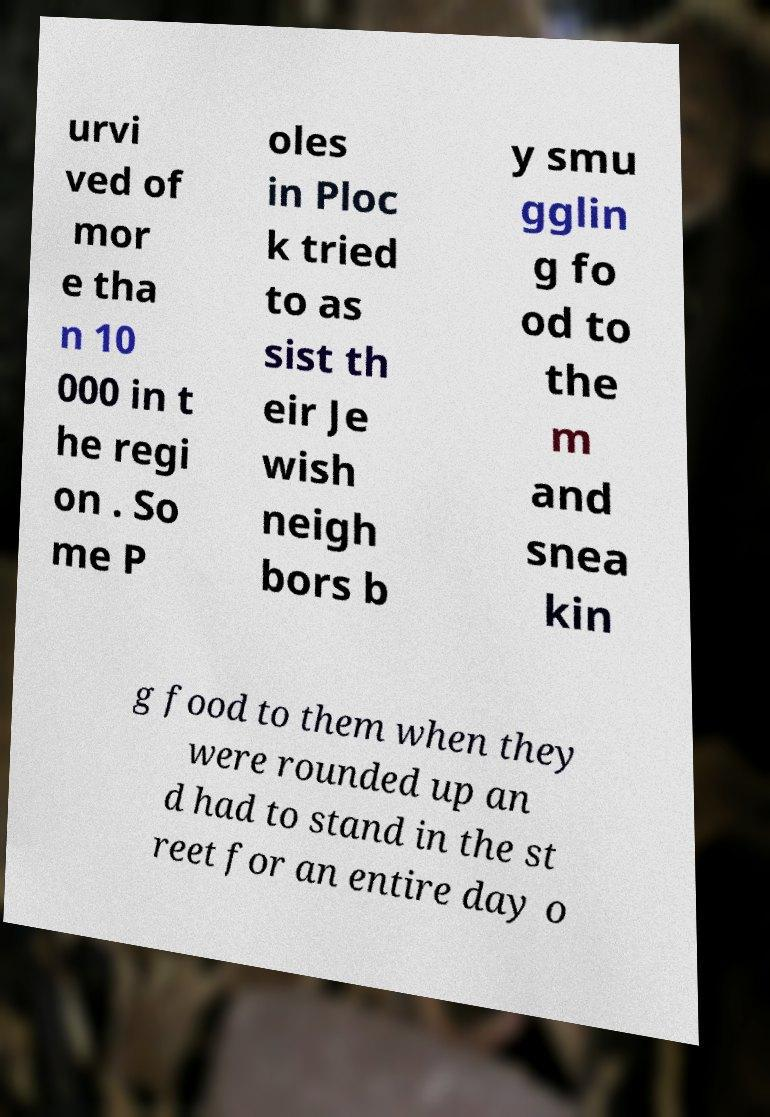Can you accurately transcribe the text from the provided image for me? urvi ved of mor e tha n 10 000 in t he regi on . So me P oles in Ploc k tried to as sist th eir Je wish neigh bors b y smu gglin g fo od to the m and snea kin g food to them when they were rounded up an d had to stand in the st reet for an entire day o 